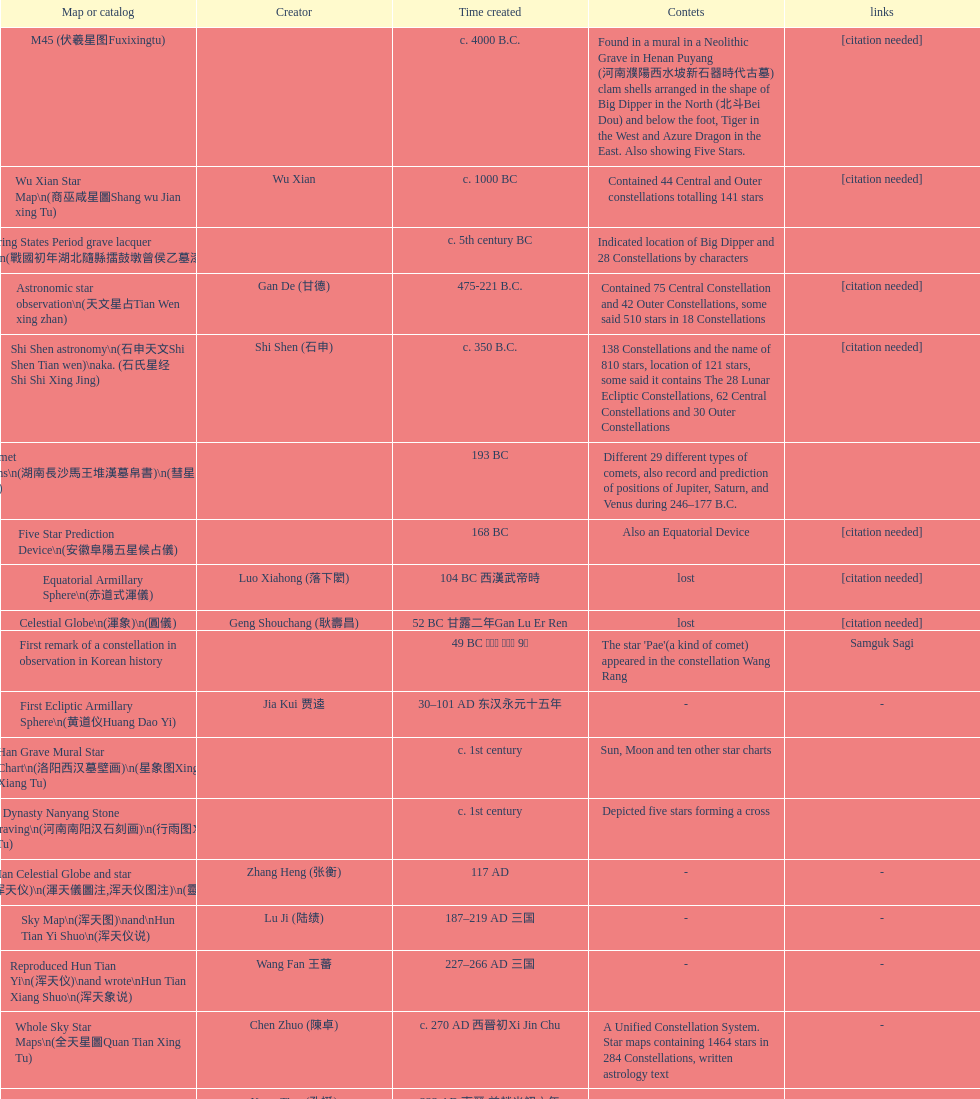Did xu guang ci or su song create the five star charts in 1094 ad? Su Song 蘇頌. 